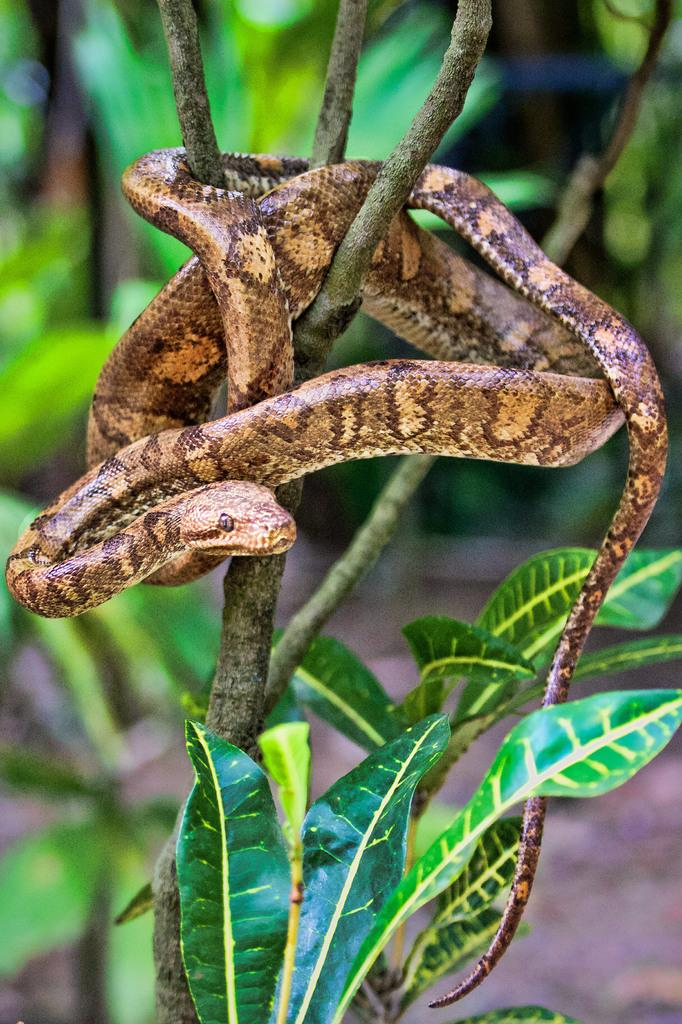What is the main object in the image? There is a tree in the image. Is there anything on the tree? Yes, there is a snake on the tree. Can you describe the background of the image? The background of the image is blurred. What type of bone can be seen in the image? There is no bone present in the image; it features a tree with a snake on it and a blurred background. 